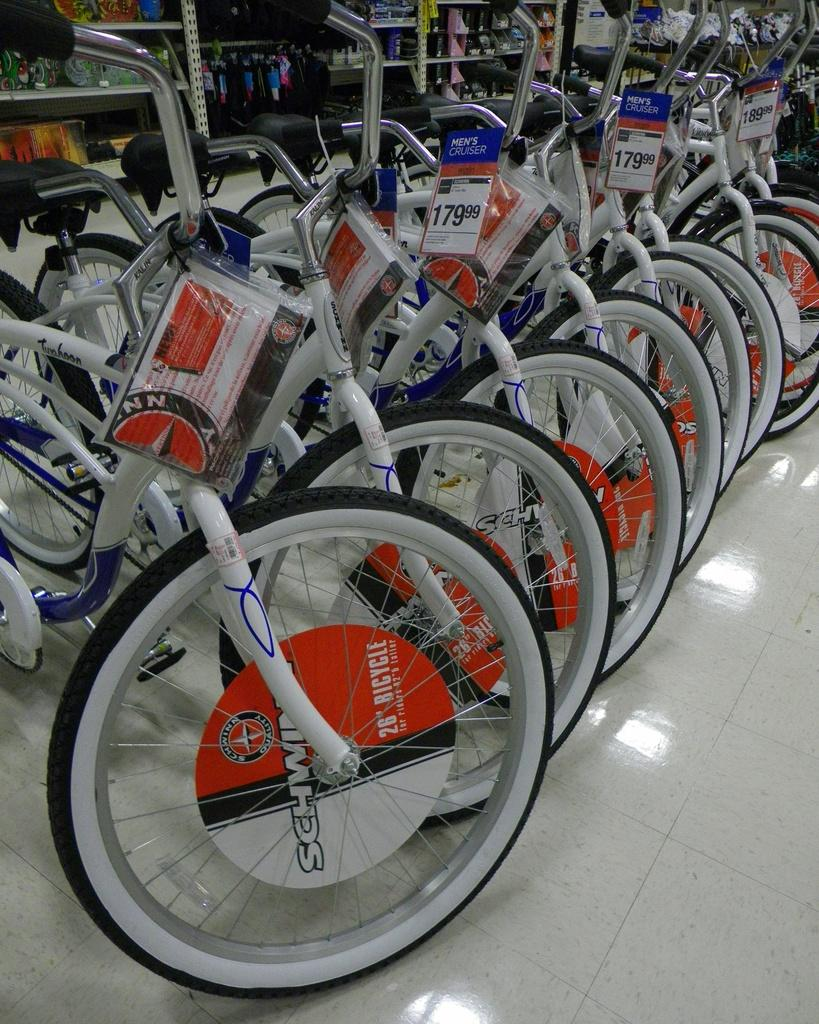What type of vehicles are in the image? There are bicycles in the image. What is the purpose of the rack in the image? The rack is used to hold items in the image. What items can be seen in the rack? Books, water bottles, and glass bottles are placed in the rack. What type of bell can be heard ringing in the image? There is no bell present in the image, and therefore no sound can be heard. 